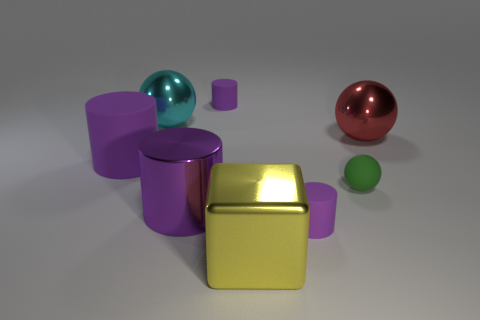Are there any green spheres that have the same size as the green rubber object?
Provide a short and direct response. No. What shape is the large thing that is the same color as the big shiny cylinder?
Offer a very short reply. Cylinder. How many purple cylinders are the same size as the cyan object?
Ensure brevity in your answer.  2. Does the metal cylinder that is to the left of the large yellow block have the same size as the metal object in front of the purple metallic thing?
Provide a succinct answer. Yes. How many things are big green objects or rubber cylinders that are behind the big cyan metal object?
Ensure brevity in your answer.  1. The block is what color?
Offer a terse response. Yellow. There is a tiny cylinder that is right of the tiny matte cylinder that is to the left of the rubber cylinder that is in front of the green matte ball; what is its material?
Offer a very short reply. Rubber. There is a cyan ball that is the same material as the cube; what is its size?
Offer a very short reply. Large. Is there another tiny metallic sphere of the same color as the tiny sphere?
Your answer should be very brief. No. Does the yellow shiny cube have the same size as the purple thing that is left of the cyan shiny thing?
Ensure brevity in your answer.  Yes. 